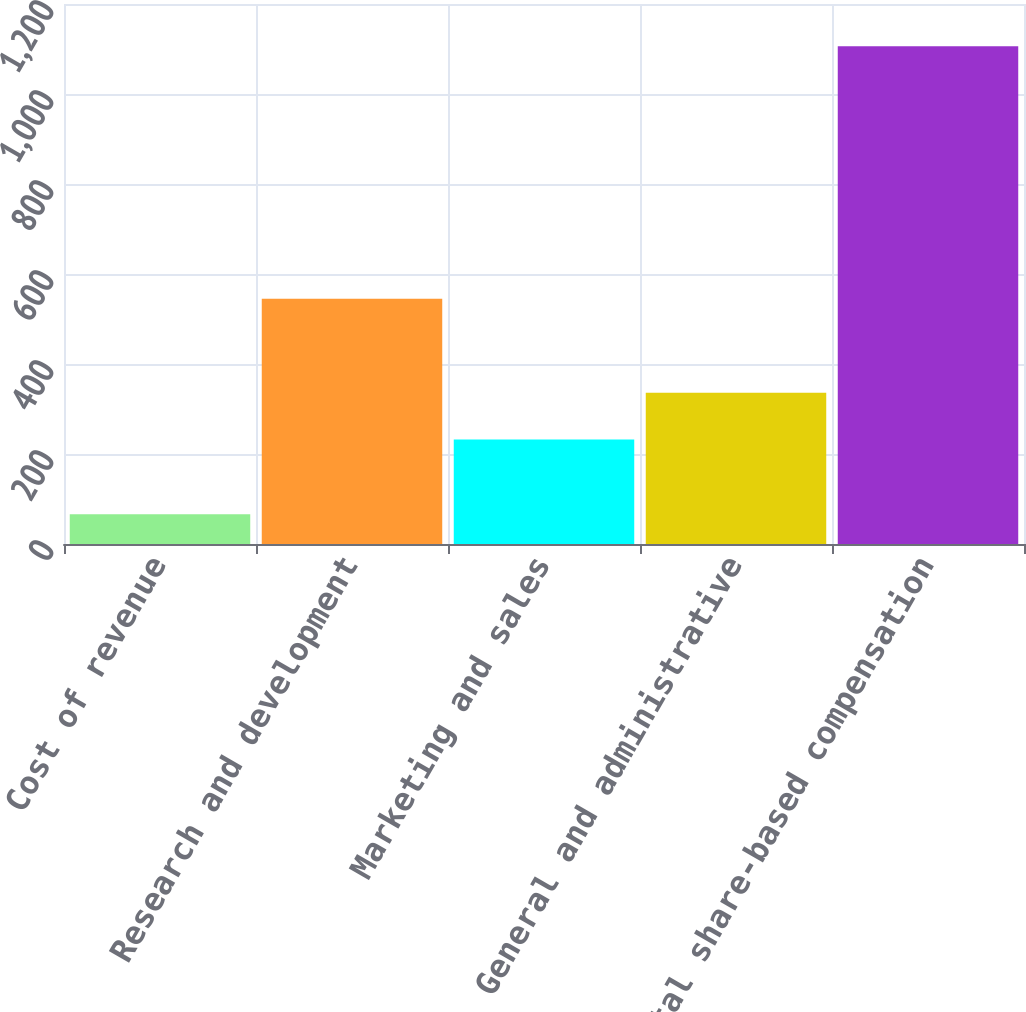<chart> <loc_0><loc_0><loc_500><loc_500><bar_chart><fcel>Cost of revenue<fcel>Research and development<fcel>Marketing and sales<fcel>General and administrative<fcel>Total share-based compensation<nl><fcel>66<fcel>545<fcel>232<fcel>336<fcel>1106<nl></chart> 